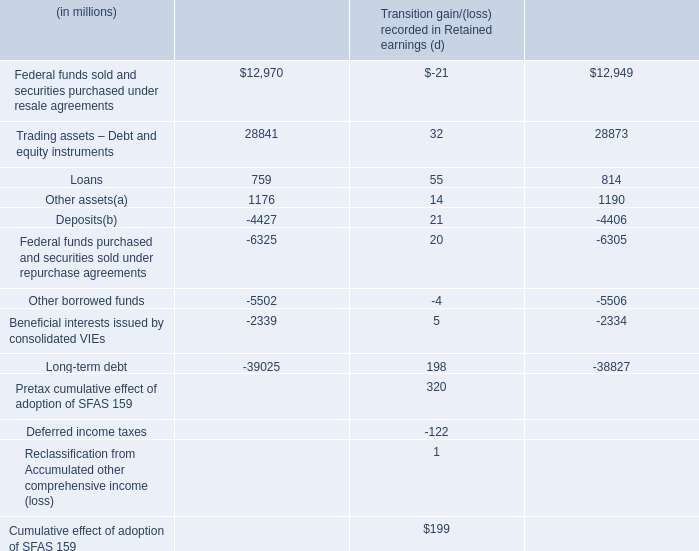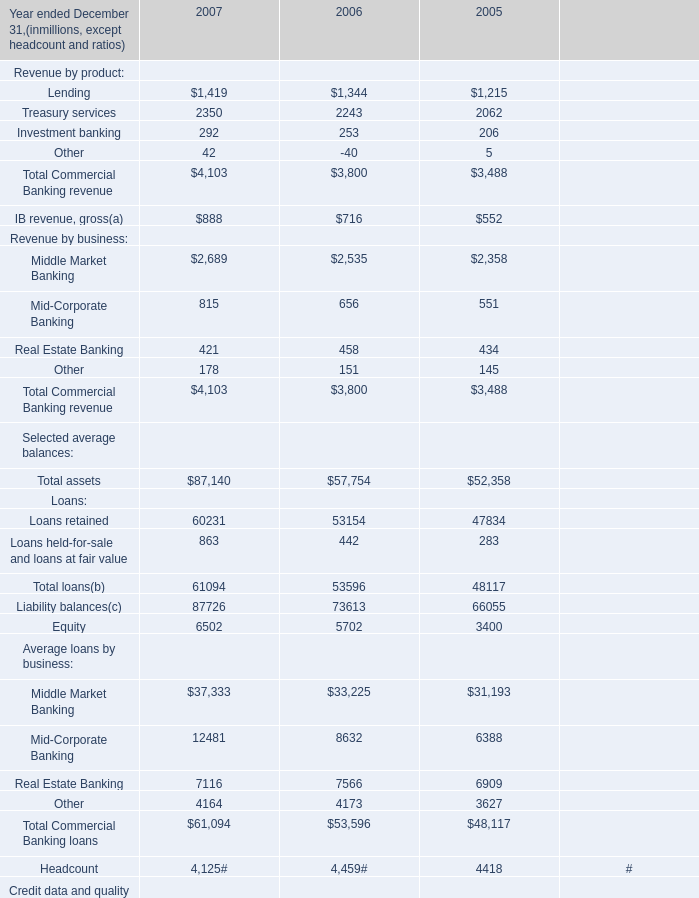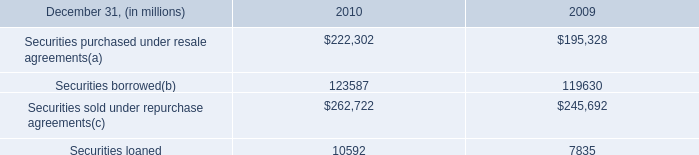in 2010 what was the percent of the securities borrowed accounted for at fair value 
Computations: (14.0 / 123587)
Answer: 0.00011. 